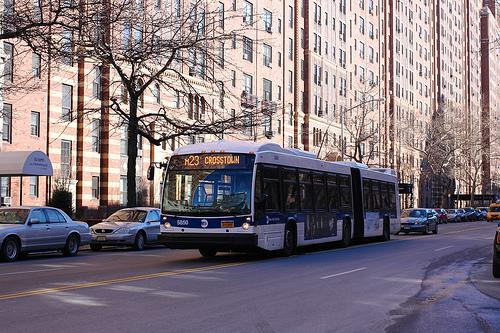Question: why are there no leaves on the tree?
Choices:
A. They fell off.
B. It's fall.
C. A giraffe ate them.
D. It's the Winter.
Answer with the letter. Answer: D Question: what does the orange words on the bus say?
Choices:
A. Downtown.
B. 3rd Avenue.
C. Winchester.
D. M23 Crosstown.
Answer with the letter. Answer: D Question: what is behind the trees?
Choices:
A. Lake.
B. More trees.
C. Cave.
D. Buildings.
Answer with the letter. Answer: D 